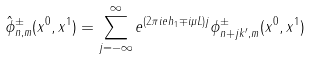Convert formula to latex. <formula><loc_0><loc_0><loc_500><loc_500>\hat { \phi } _ { n , m } ^ { \pm } ( x ^ { 0 } , x ^ { 1 } ) = \sum _ { j = - \infty } ^ { \infty } e ^ { ( 2 \pi i e h _ { 1 } \mp i \mu L ) j } \phi _ { n + j k ^ { \prime } , m } ^ { \pm } ( x ^ { 0 } , x ^ { 1 } )</formula> 